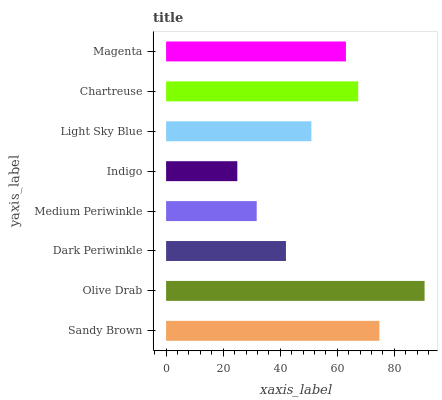Is Indigo the minimum?
Answer yes or no. Yes. Is Olive Drab the maximum?
Answer yes or no. Yes. Is Dark Periwinkle the minimum?
Answer yes or no. No. Is Dark Periwinkle the maximum?
Answer yes or no. No. Is Olive Drab greater than Dark Periwinkle?
Answer yes or no. Yes. Is Dark Periwinkle less than Olive Drab?
Answer yes or no. Yes. Is Dark Periwinkle greater than Olive Drab?
Answer yes or no. No. Is Olive Drab less than Dark Periwinkle?
Answer yes or no. No. Is Magenta the high median?
Answer yes or no. Yes. Is Light Sky Blue the low median?
Answer yes or no. Yes. Is Chartreuse the high median?
Answer yes or no. No. Is Sandy Brown the low median?
Answer yes or no. No. 